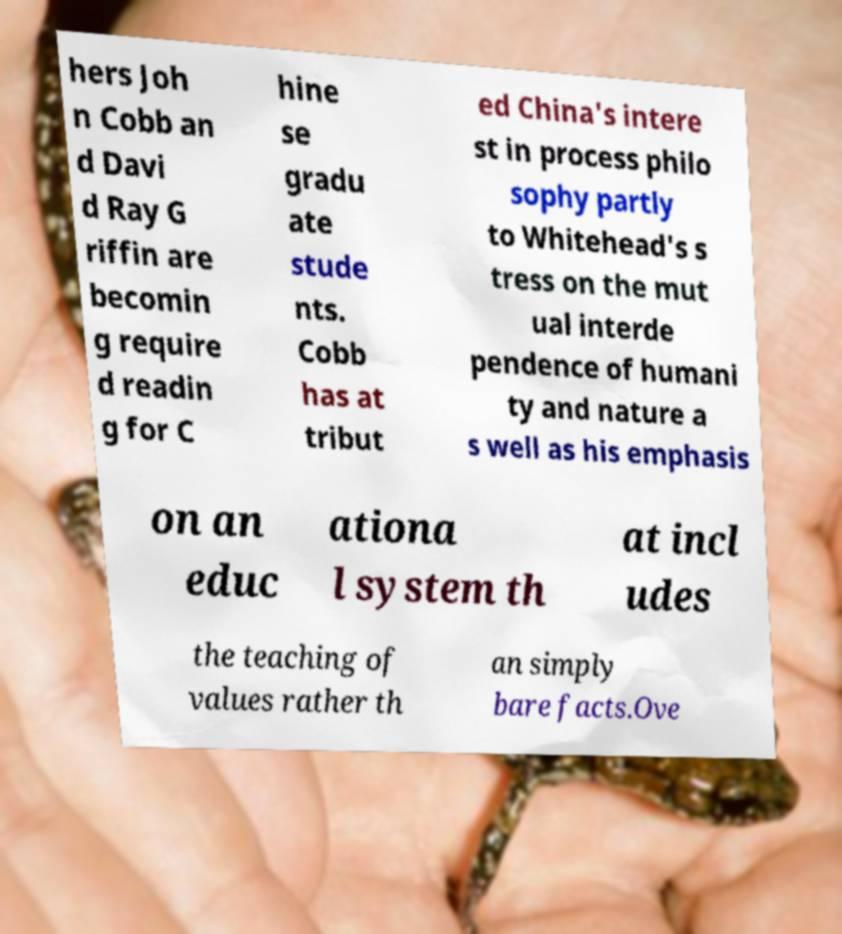For documentation purposes, I need the text within this image transcribed. Could you provide that? hers Joh n Cobb an d Davi d Ray G riffin are becomin g require d readin g for C hine se gradu ate stude nts. Cobb has at tribut ed China's intere st in process philo sophy partly to Whitehead's s tress on the mut ual interde pendence of humani ty and nature a s well as his emphasis on an educ ationa l system th at incl udes the teaching of values rather th an simply bare facts.Ove 